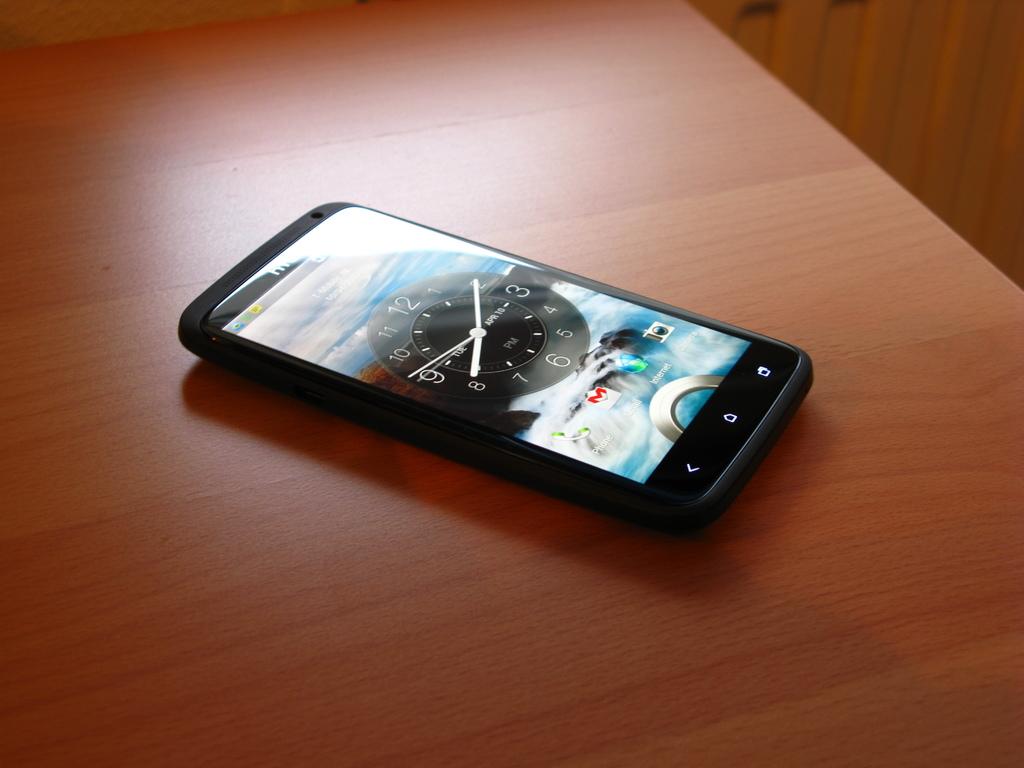What is the hour hand pointed to?
Provide a short and direct response. 8. What kind of phone is this?
Your answer should be compact. Htc. 